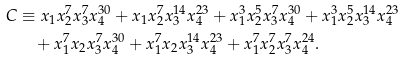Convert formula to latex. <formula><loc_0><loc_0><loc_500><loc_500>C & \equiv x _ { 1 } x _ { 2 } ^ { 7 } x _ { 3 } ^ { 7 } x _ { 4 } ^ { 3 0 } + x _ { 1 } x _ { 2 } ^ { 7 } x _ { 3 } ^ { 1 4 } x _ { 4 } ^ { 2 3 } + x _ { 1 } ^ { 3 } x _ { 2 } ^ { 5 } x _ { 3 } ^ { 7 } x _ { 4 } ^ { 3 0 } + x _ { 1 } ^ { 3 } x _ { 2 } ^ { 5 } x _ { 3 } ^ { 1 4 } x _ { 4 } ^ { 2 3 } \\ & \quad + x _ { 1 } ^ { 7 } x _ { 2 } x _ { 3 } ^ { 7 } x _ { 4 } ^ { 3 0 } + x _ { 1 } ^ { 7 } x _ { 2 } x _ { 3 } ^ { 1 4 } x _ { 4 } ^ { 2 3 } + x _ { 1 } ^ { 7 } x _ { 2 } ^ { 7 } x _ { 3 } ^ { 7 } x _ { 4 } ^ { 2 4 } .</formula> 